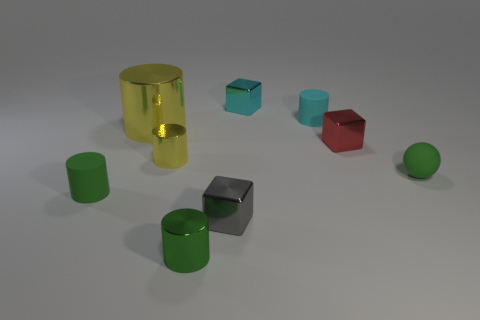Which objects in this image could function as containers? The reflective yellow cylinder on the left looks like it could function as a container due to its hollow shape, although without a lid, its capacity to securely contain items could be compromised. 